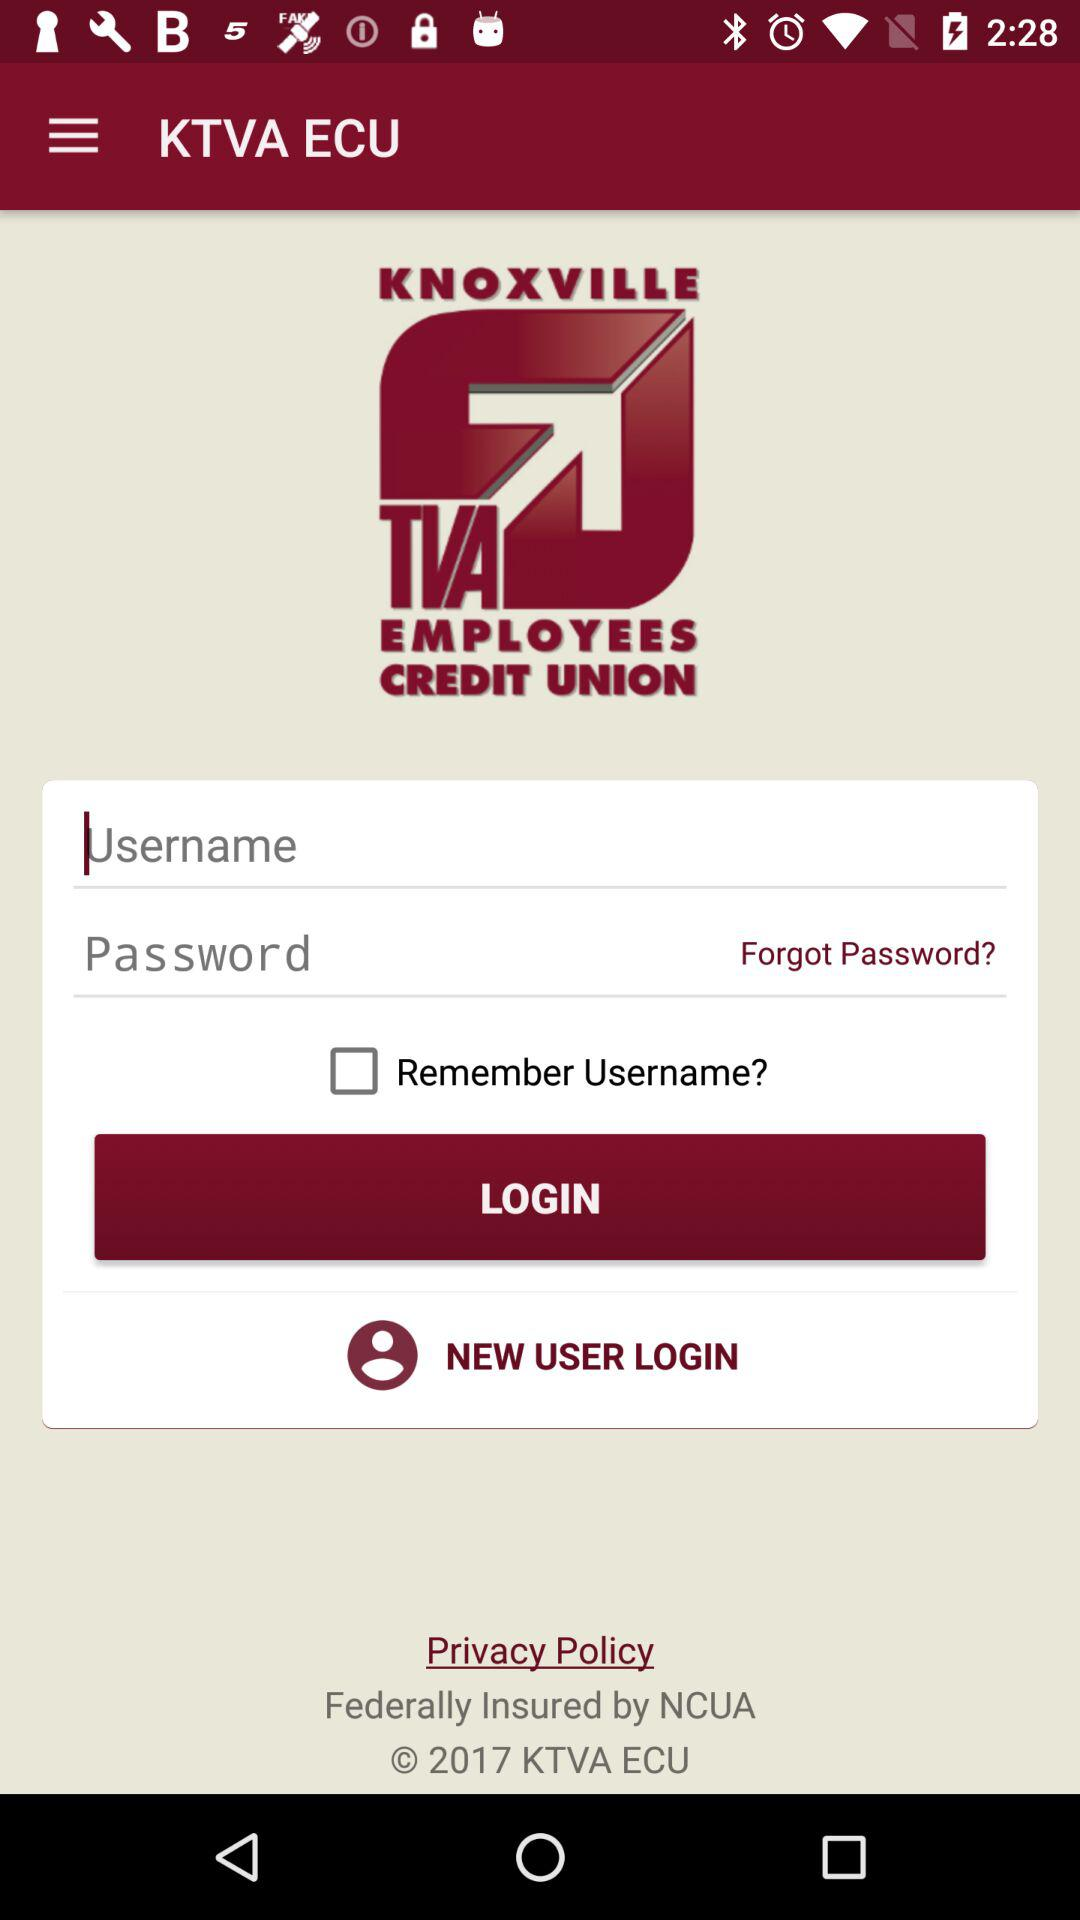What is the application name? The application name is "KNOXVILLE TVA EMPLOYEES CREDIT UNION". 